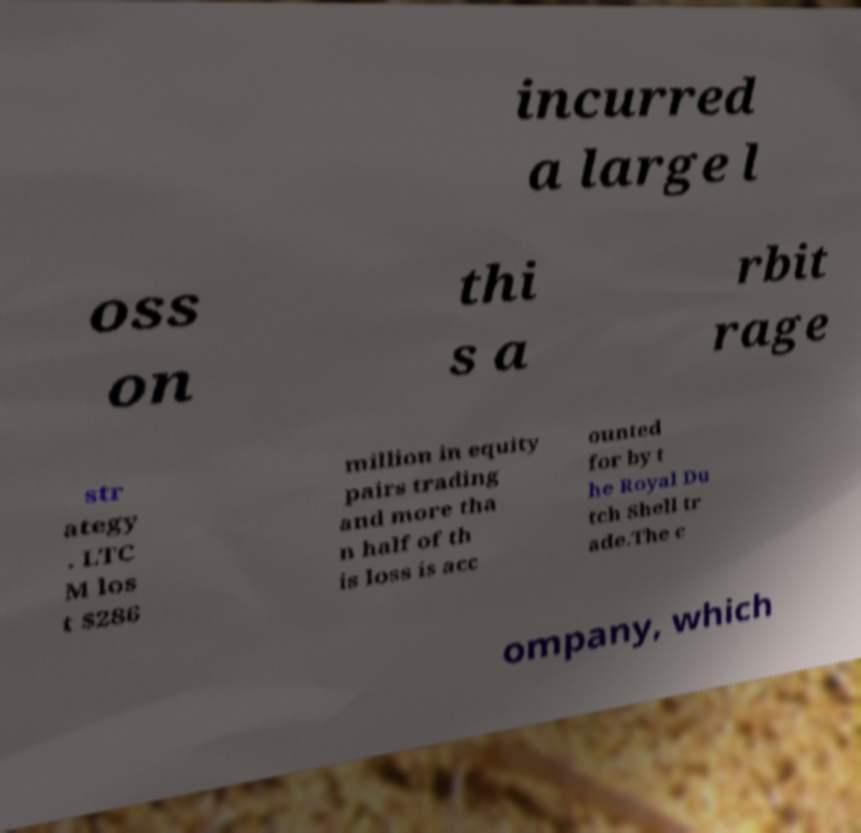Could you assist in decoding the text presented in this image and type it out clearly? incurred a large l oss on thi s a rbit rage str ategy . LTC M los t $286 million in equity pairs trading and more tha n half of th is loss is acc ounted for by t he Royal Du tch Shell tr ade.The c ompany, which 